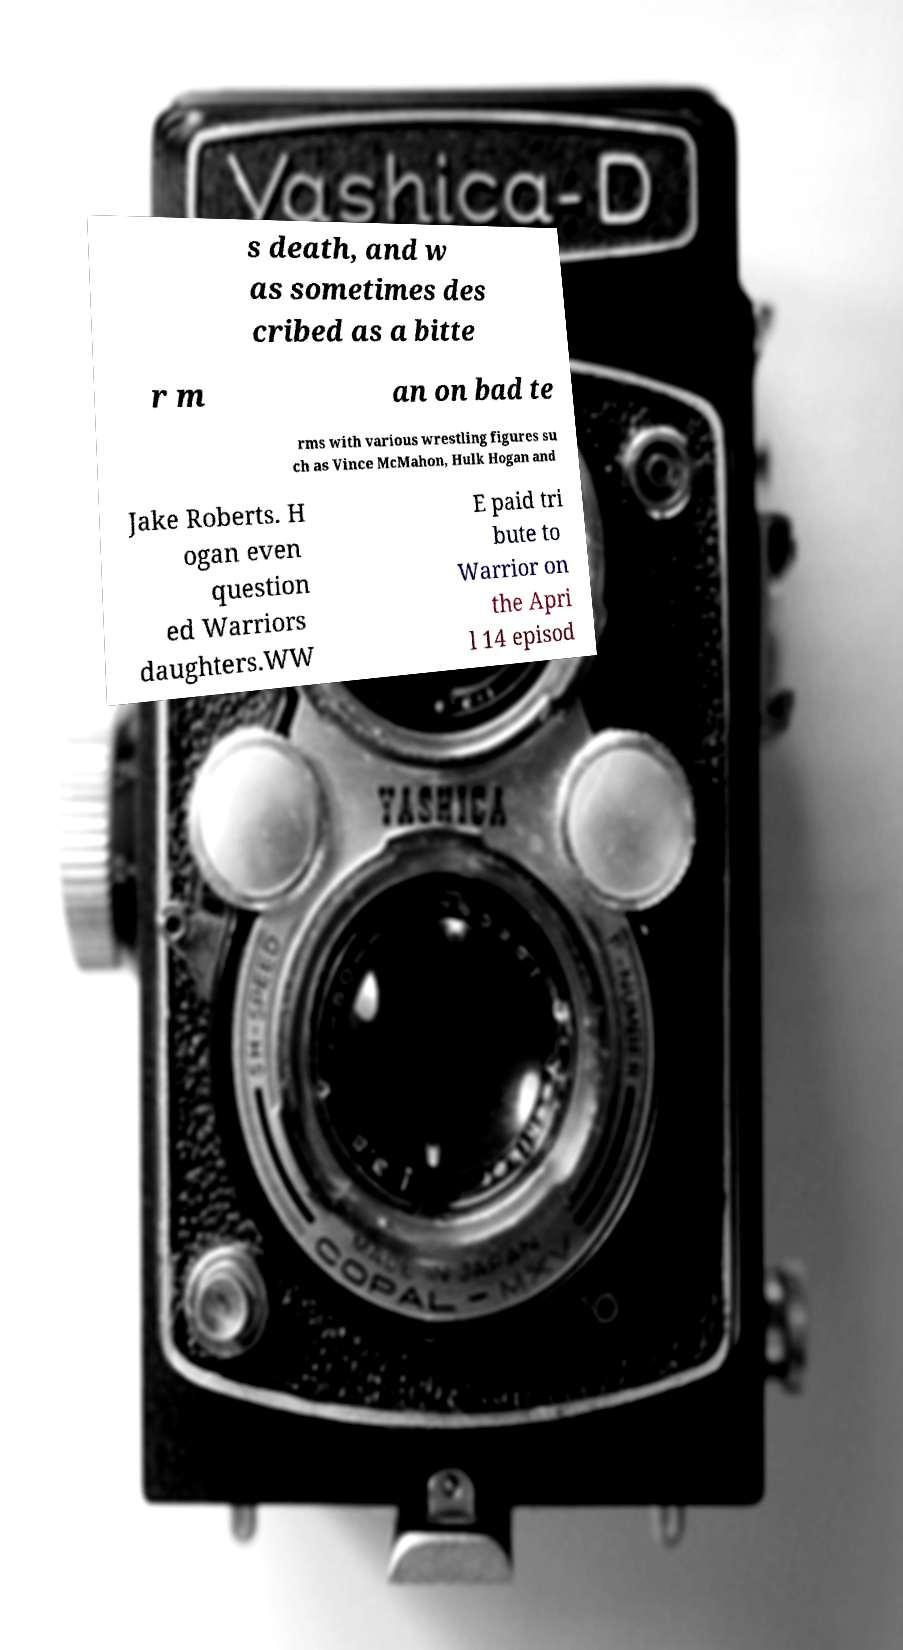What messages or text are displayed in this image? I need them in a readable, typed format. s death, and w as sometimes des cribed as a bitte r m an on bad te rms with various wrestling figures su ch as Vince McMahon, Hulk Hogan and Jake Roberts. H ogan even question ed Warriors daughters.WW E paid tri bute to Warrior on the Apri l 14 episod 